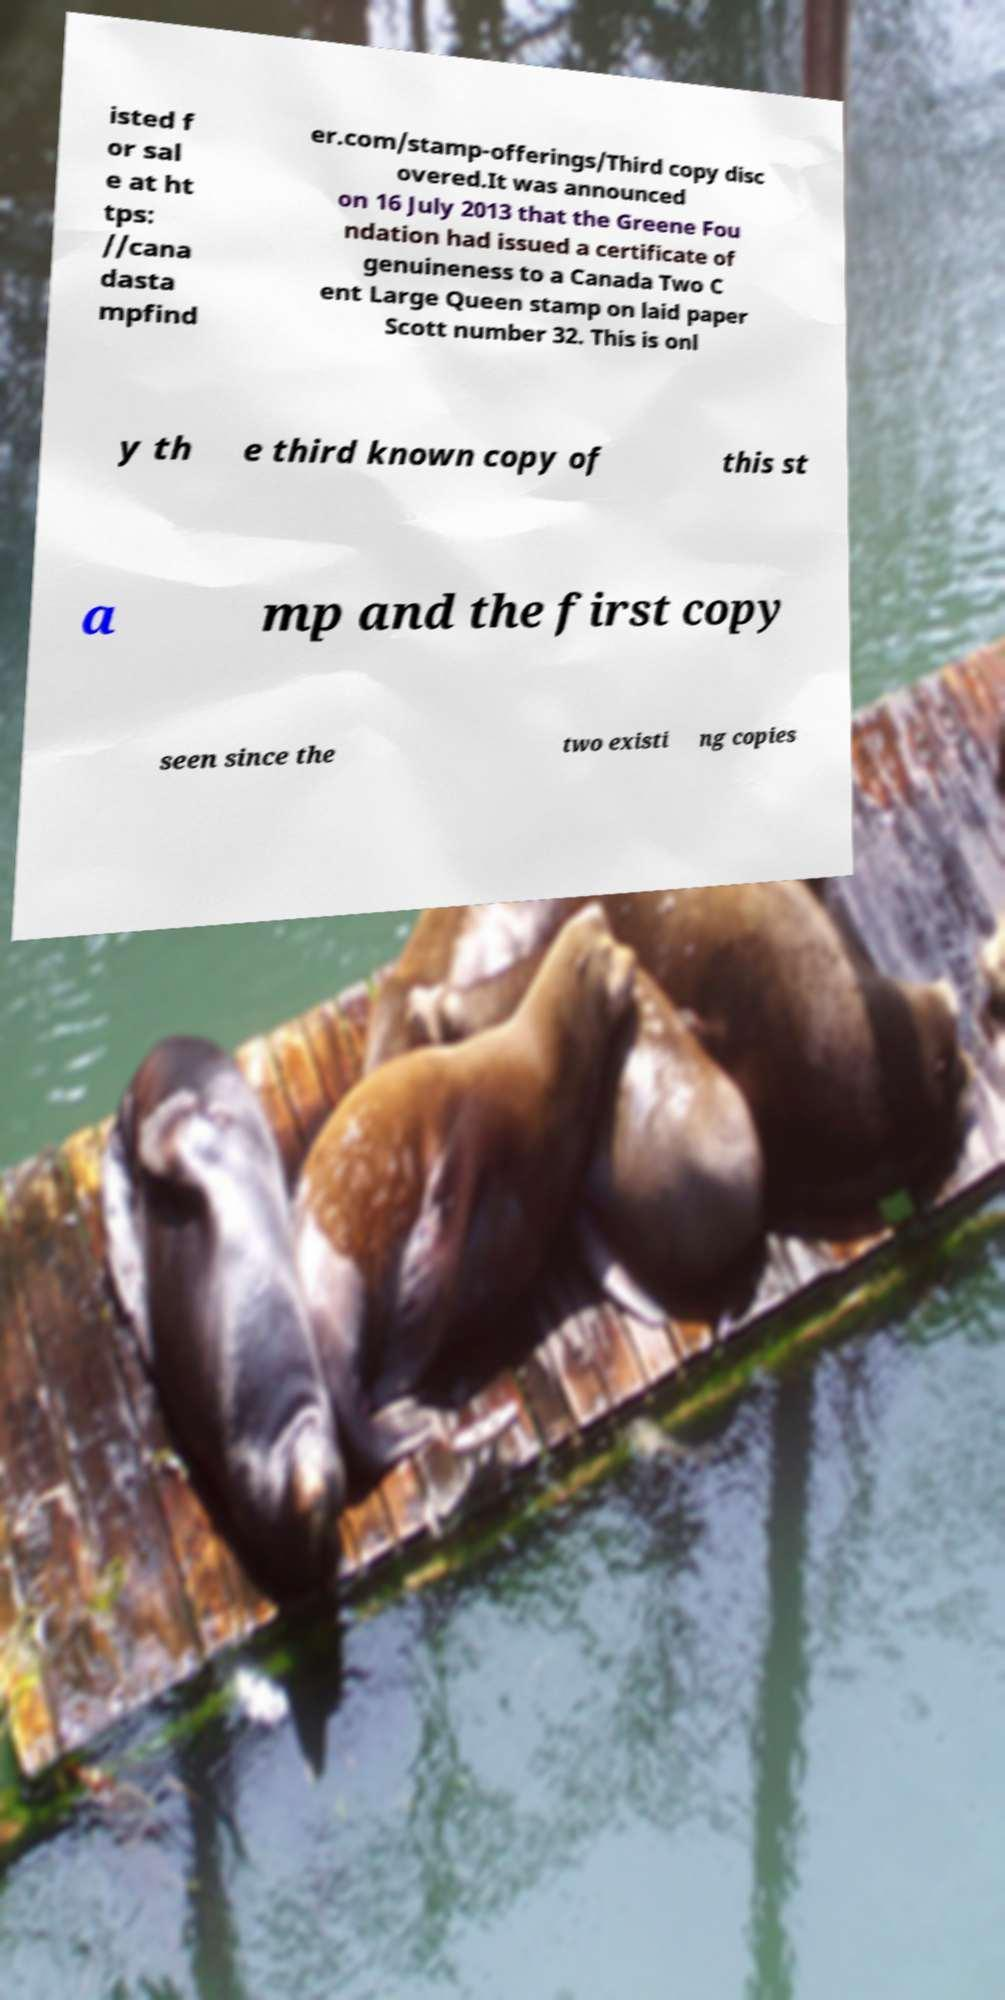What messages or text are displayed in this image? I need them in a readable, typed format. isted f or sal e at ht tps: //cana dasta mpfind er.com/stamp-offerings/Third copy disc overed.It was announced on 16 July 2013 that the Greene Fou ndation had issued a certificate of genuineness to a Canada Two C ent Large Queen stamp on laid paper Scott number 32. This is onl y th e third known copy of this st a mp and the first copy seen since the two existi ng copies 